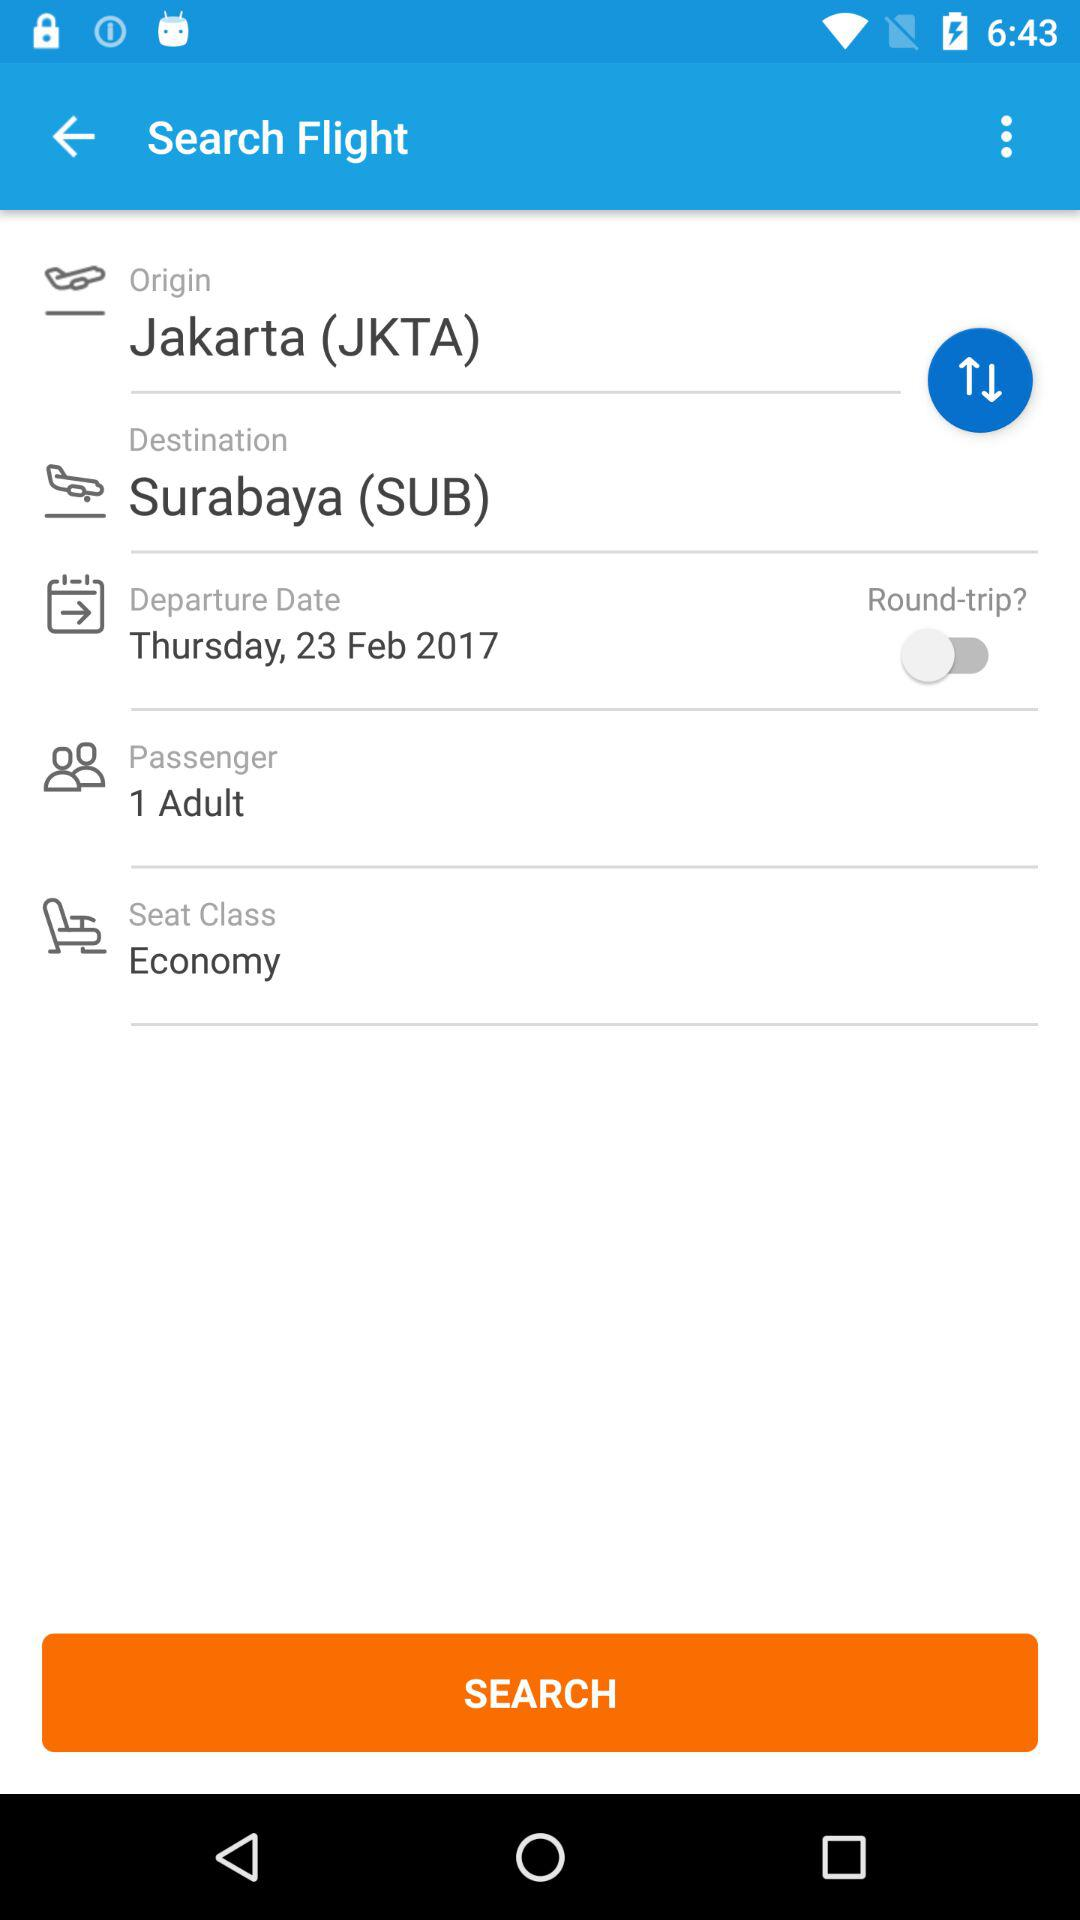What is the status of the "Round-trip?"? The status is "off". 